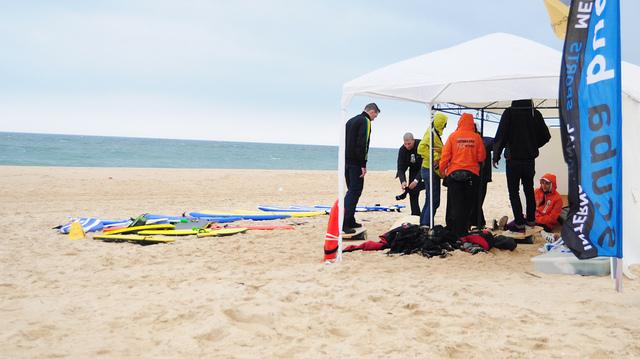What are they doing under the canopy? Please explain your reasoning. changing clothes. With all the garments on the ground, that looks like what they're doing. 